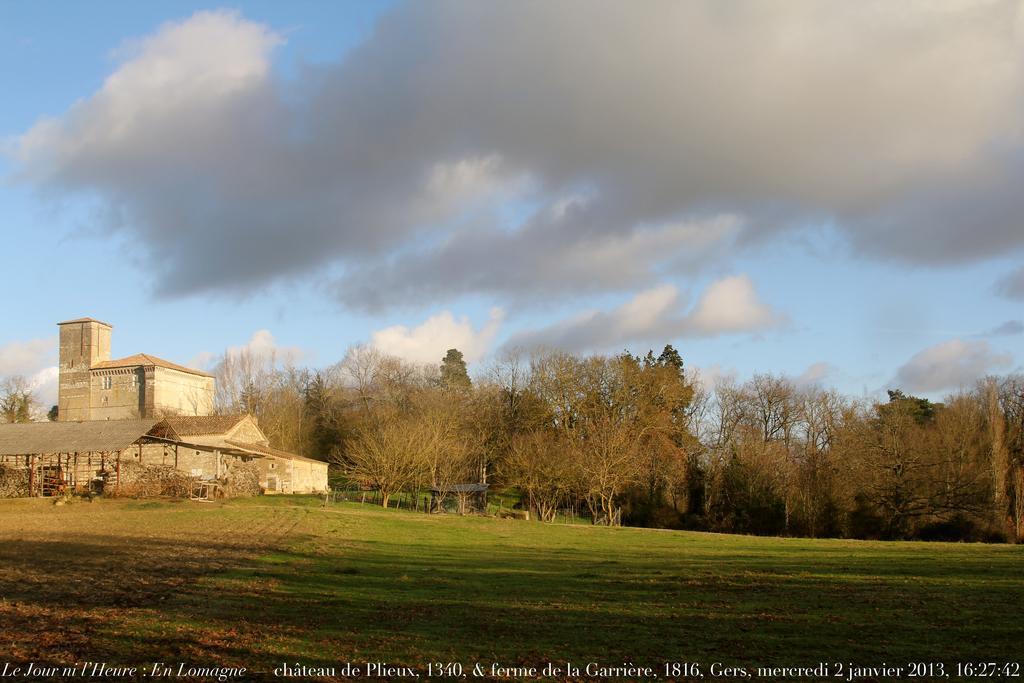In one or two sentences, can you explain what this image depicts? In this picture we can see a building, shelter, trees, grass and in the background we can see the sky with clouds. 